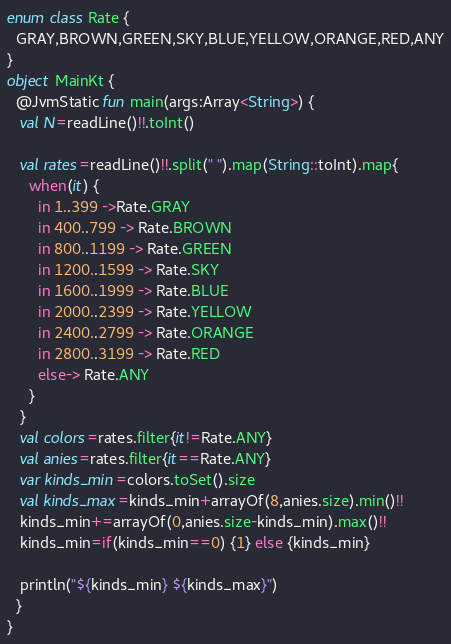Convert code to text. <code><loc_0><loc_0><loc_500><loc_500><_Kotlin_>enum class Rate {
  GRAY,BROWN,GREEN,SKY,BLUE,YELLOW,ORANGE,RED,ANY
}
object MainKt {
  @JvmStatic fun main(args:Array<String>) {
   val N=readLine()!!.toInt()

   val rates=readLine()!!.split(" ").map(String::toInt).map{
     when(it) {
       in 1..399 ->Rate.GRAY
       in 400..799 -> Rate.BROWN
       in 800..1199 -> Rate.GREEN
       in 1200..1599 -> Rate.SKY
       in 1600..1999 -> Rate.BLUE
       in 2000..2399 -> Rate.YELLOW
       in 2400..2799 -> Rate.ORANGE
       in 2800..3199 -> Rate.RED
       else-> Rate.ANY
     }
   }
   val colors=rates.filter{it!=Rate.ANY}
   val anies=rates.filter{it==Rate.ANY}
   var kinds_min=colors.toSet().size
   val kinds_max=kinds_min+arrayOf(8,anies.size).min()!!
   kinds_min+=arrayOf(0,anies.size-kinds_min).max()!!
   kinds_min=if(kinds_min==0) {1} else {kinds_min}
  
   println("${kinds_min} ${kinds_max}")
  }
}
</code> 